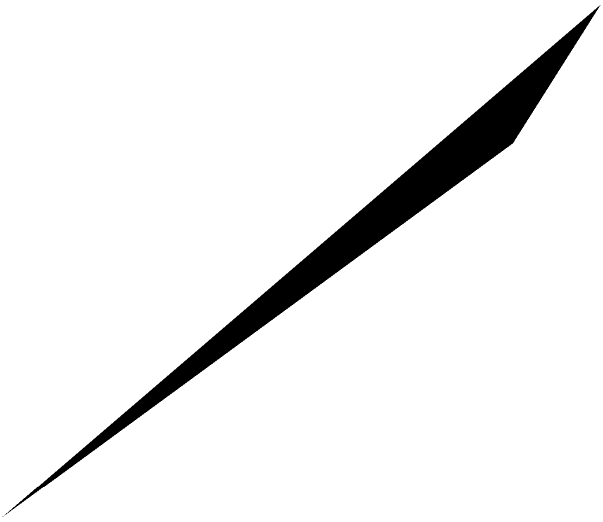Given three non-collinear points $A(1,2,3)$, $B(2,0,1)$, and $C(-1,1,2)$ in three-dimensional space, determine the equation of the plane passing through these points in the form $ax + by + cz + d = 0$, where $a$, $b$, $c$, and $d$ are constants and $a$, $b$, and $c$ are not all zero. To find the equation of the plane passing through three non-collinear points, we can follow these steps:

1) First, we need to find two vectors in the plane. We can do this by subtracting the coordinates of two points from the third:

   $\vec{AB} = B - A = (2,0,1) - (1,2,3) = (1,-2,-2)$
   $\vec{AC} = C - A = (-1,1,2) - (1,2,3) = (-2,-1,-1)$

2) The normal vector to the plane will be the cross product of these two vectors:

   $\vec{n} = \vec{AB} \times \vec{AC} = \begin{vmatrix} 
   i & j & k \\
   1 & -2 & -2 \\
   -2 & -1 & -1
   \end{vmatrix} = (-2-2)i + (-2+4)j + (-1+4)k = -4i + 2j + 3k$

3) So, the normal vector is $\vec{n} = (-4, 2, 3)$. This gives us the coefficients $a=-4$, $b=2$, and $c=3$ in the plane equation.

4) To find $d$, we can substitute the coordinates of any of the given points into the equation $ax + by + cz + d = 0$. Let's use point A(1,2,3):

   $-4(1) + 2(2) + 3(3) + d = 0$
   $-4 + 4 + 9 + d = 0$
   $9 + d = 0$
   $d = -9$

5) Therefore, the equation of the plane is:

   $-4x + 2y + 3z - 9 = 0$

We can simplify this by dividing all terms by -1 to make the constant term positive:

   $4x - 2y - 3z + 9 = 0$

This is the final equation of the plane passing through the given points.
Answer: $4x - 2y - 3z + 9 = 0$ 